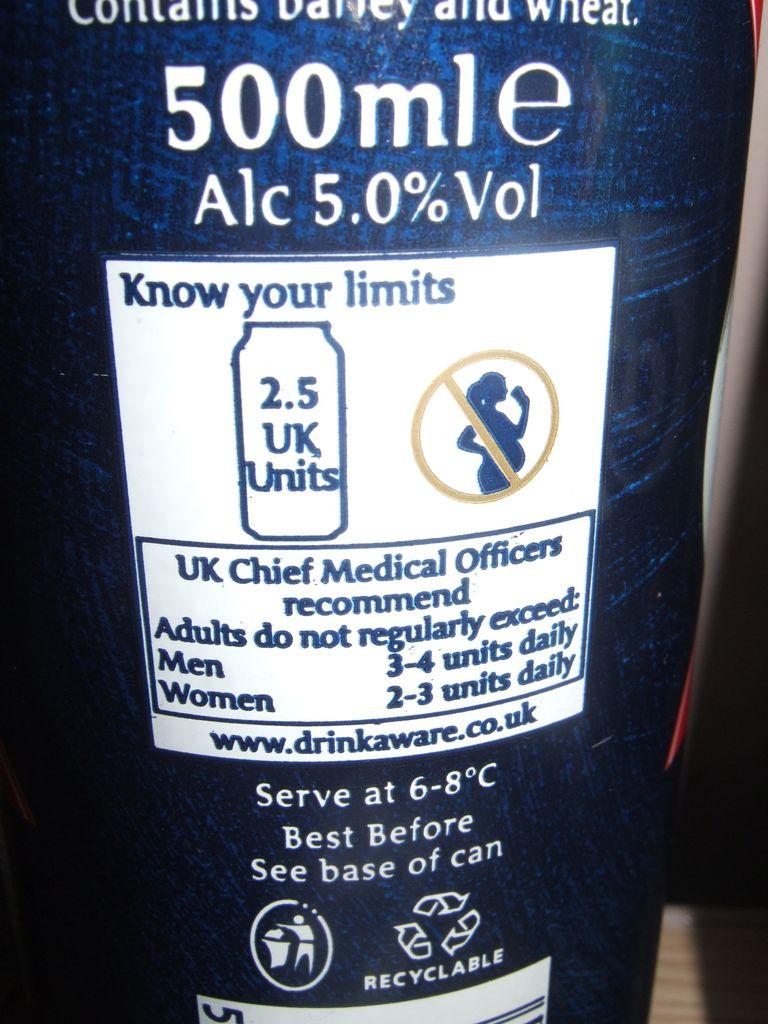How much alcohol?
Offer a very short reply. 5.0%. What is the website address?
Your answer should be very brief. Www.drinkaware.co.uk. 